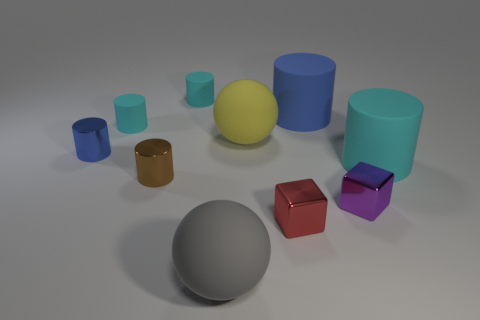Are there any patterns or textures on the objects that stand out to you? The objects in the image are rendered with matte finishes, which means they diffuse light without significant reflection, thereby emphasizing their solid colors without the distraction of surface patterns or textures. 